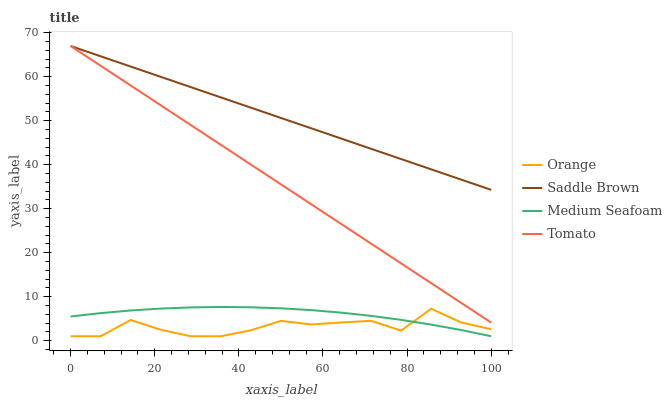Does Orange have the minimum area under the curve?
Answer yes or no. Yes. Does Saddle Brown have the maximum area under the curve?
Answer yes or no. Yes. Does Tomato have the minimum area under the curve?
Answer yes or no. No. Does Tomato have the maximum area under the curve?
Answer yes or no. No. Is Saddle Brown the smoothest?
Answer yes or no. Yes. Is Orange the roughest?
Answer yes or no. Yes. Is Tomato the smoothest?
Answer yes or no. No. Is Tomato the roughest?
Answer yes or no. No. Does Orange have the lowest value?
Answer yes or no. Yes. Does Tomato have the lowest value?
Answer yes or no. No. Does Saddle Brown have the highest value?
Answer yes or no. Yes. Does Medium Seafoam have the highest value?
Answer yes or no. No. Is Orange less than Tomato?
Answer yes or no. Yes. Is Tomato greater than Orange?
Answer yes or no. Yes. Does Medium Seafoam intersect Orange?
Answer yes or no. Yes. Is Medium Seafoam less than Orange?
Answer yes or no. No. Is Medium Seafoam greater than Orange?
Answer yes or no. No. Does Orange intersect Tomato?
Answer yes or no. No. 